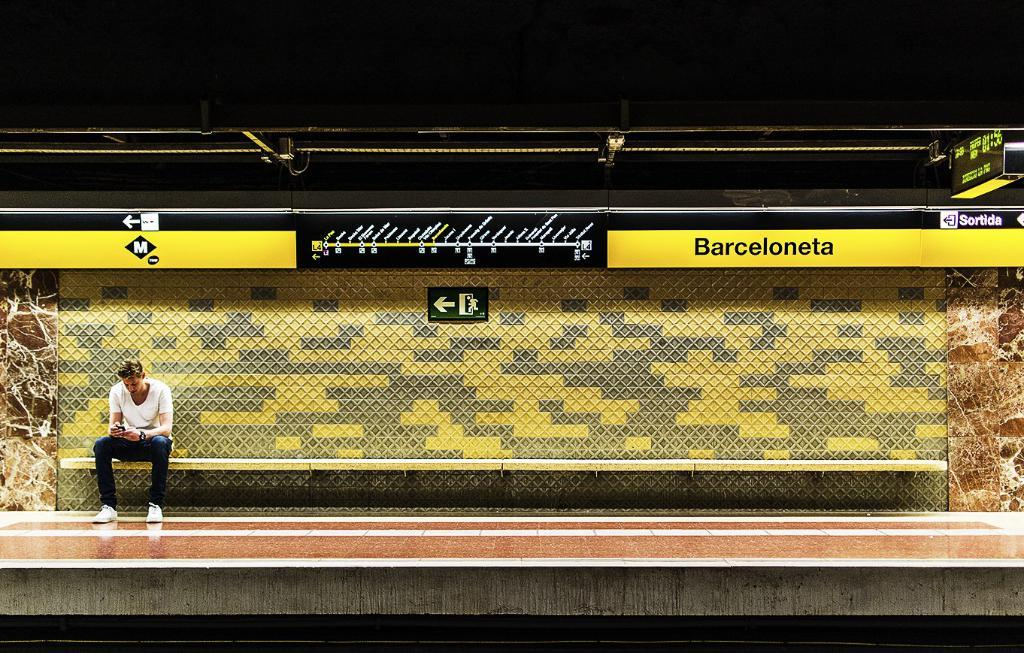What is the man doing in the image? The man is sitting on the left side of the image. What is the man wearing on his upper body? The man is wearing a white t-shirt. What type of trousers is the man wearing? The man is wearing jeans trousers. What type of shoes is the man wearing? The man is wearing white shoes. What is the title of the book the man is reading in the image? There is no book present in the image, so it is not possible to determine the title. 